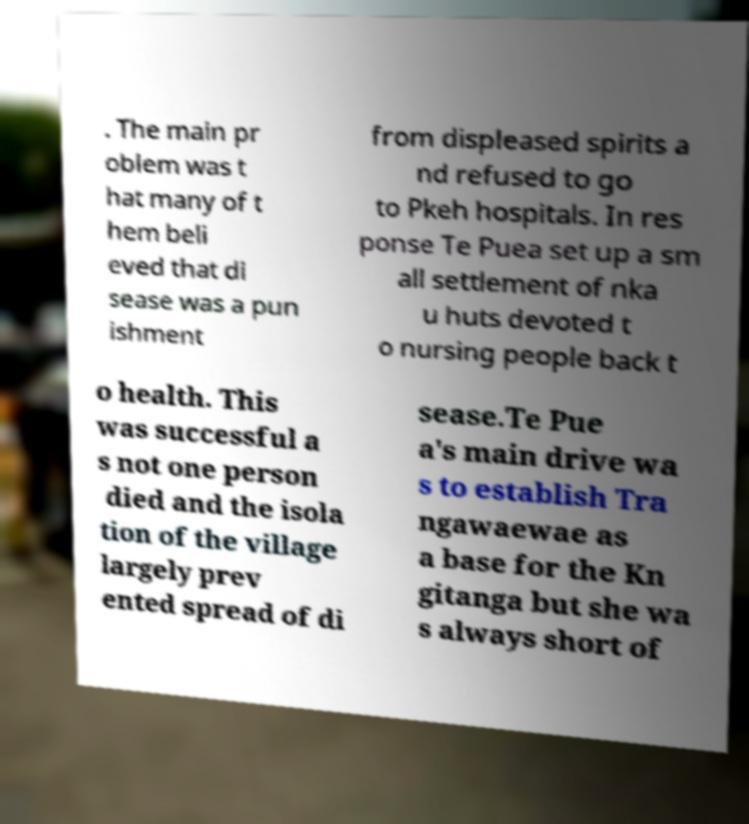Please identify and transcribe the text found in this image. . The main pr oblem was t hat many of t hem beli eved that di sease was a pun ishment from displeased spirits a nd refused to go to Pkeh hospitals. In res ponse Te Puea set up a sm all settlement of nka u huts devoted t o nursing people back t o health. This was successful a s not one person died and the isola tion of the village largely prev ented spread of di sease.Te Pue a's main drive wa s to establish Tra ngawaewae as a base for the Kn gitanga but she wa s always short of 